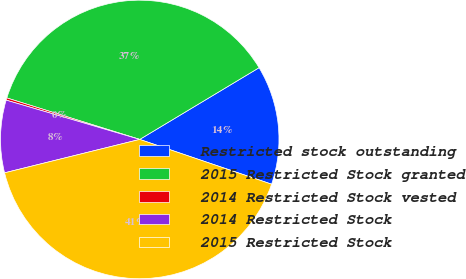Convert chart. <chart><loc_0><loc_0><loc_500><loc_500><pie_chart><fcel>Restricted stock outstanding<fcel>2015 Restricted Stock granted<fcel>2014 Restricted Stock vested<fcel>2014 Restricted Stock<fcel>2015 Restricted Stock<nl><fcel>13.82%<fcel>36.57%<fcel>0.26%<fcel>8.41%<fcel>40.93%<nl></chart> 